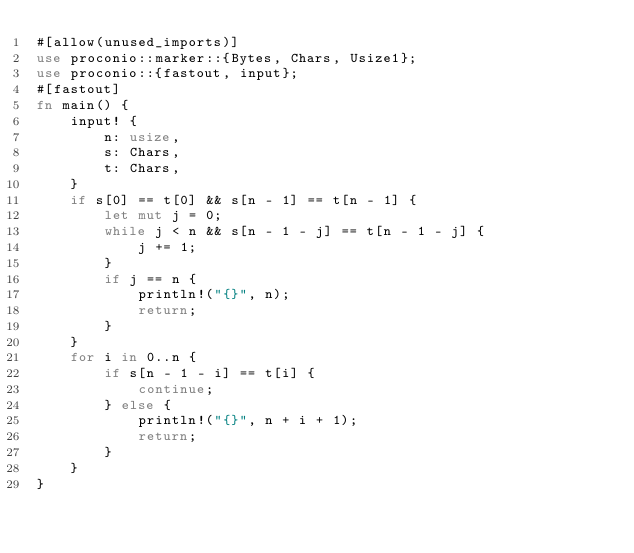Convert code to text. <code><loc_0><loc_0><loc_500><loc_500><_Rust_>#[allow(unused_imports)]
use proconio::marker::{Bytes, Chars, Usize1};
use proconio::{fastout, input};
#[fastout]
fn main() {
    input! {
        n: usize,
        s: Chars,
        t: Chars,
    }
    if s[0] == t[0] && s[n - 1] == t[n - 1] {
        let mut j = 0;
        while j < n && s[n - 1 - j] == t[n - 1 - j] {
            j += 1;
        }
        if j == n {
            println!("{}", n);
            return;
        }
    }
    for i in 0..n {
        if s[n - 1 - i] == t[i] {
            continue;
        } else {
            println!("{}", n + i + 1);
            return;
        }
    }
}
</code> 